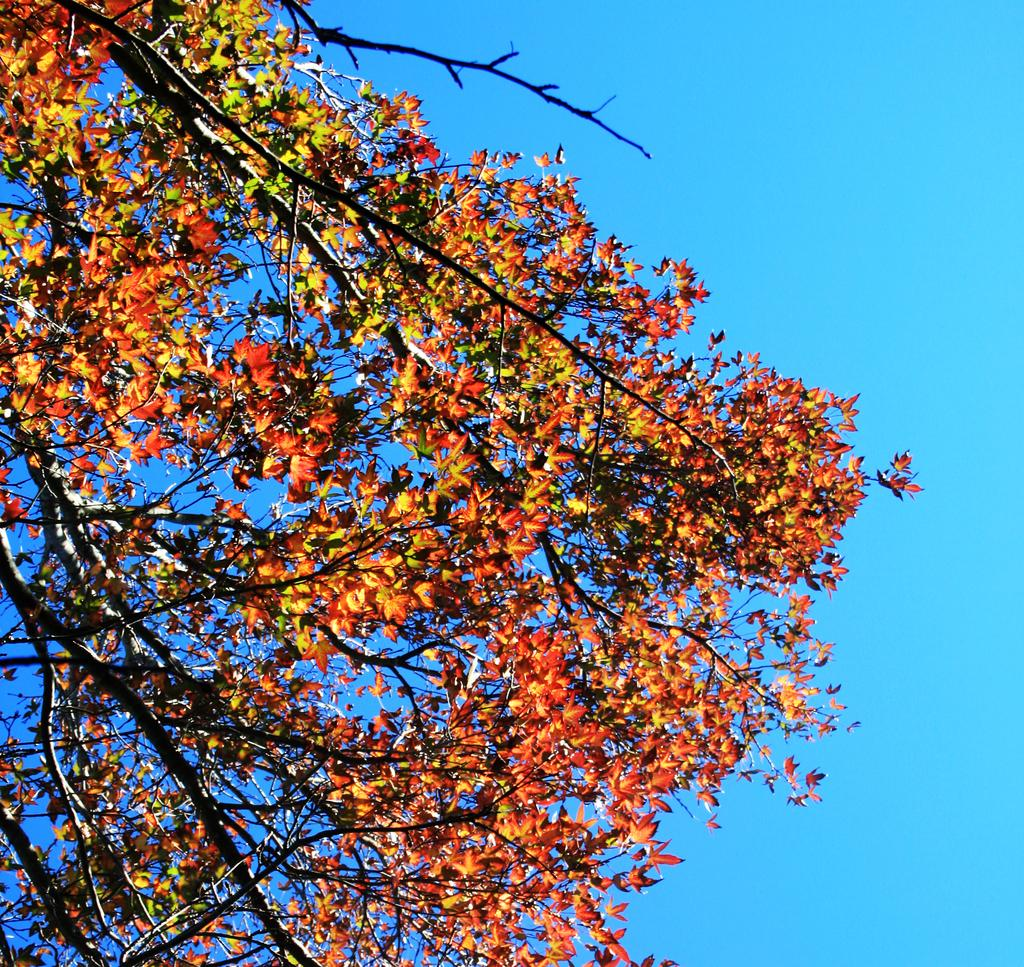What can be seen in the image that belongs to a tree? There are tree branches in the image. What is present on the tree branches? The tree branches have leaves. What color are the leaves on the tree branches? The leaves are in orange color. What type of carriage can be seen in the image? There is no carriage present in the image; it features tree branches with orange leaves. What kind of noise is being made by the leaves in the image? The image is still, so there is no noise being made by the leaves. 